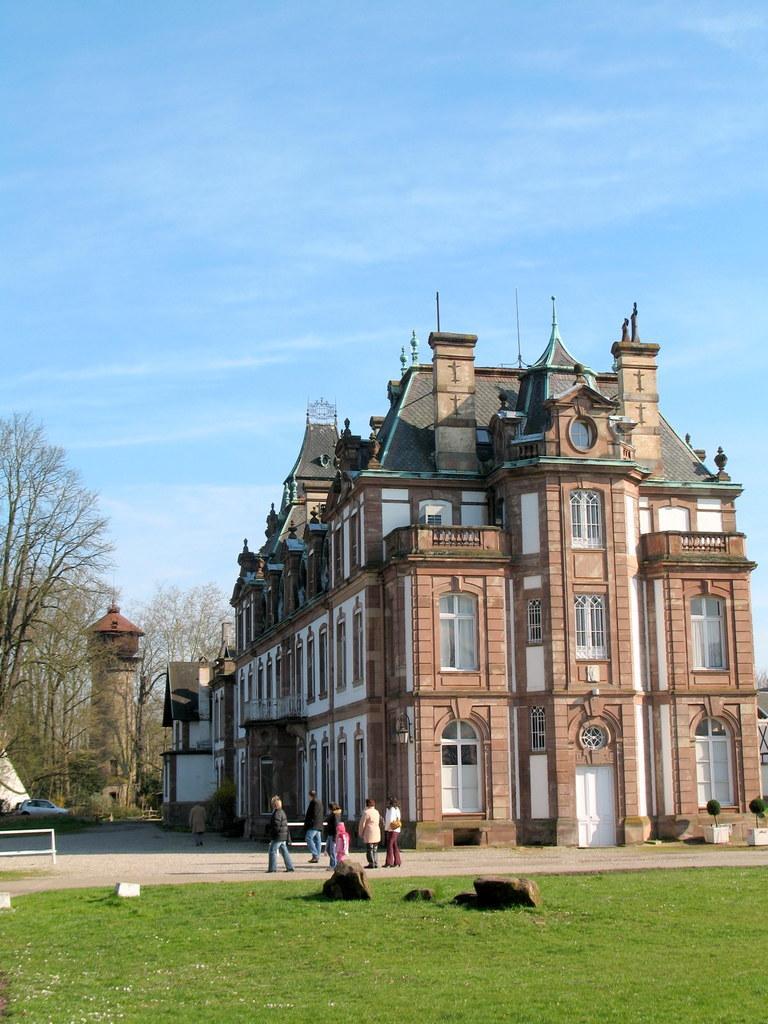Please provide a concise description of this image. At the bottom of the image there is grass. In the background of the image there is a buildings. There are trees. There are people walking on the road at the center of the image. At the top of the image there is sky. 